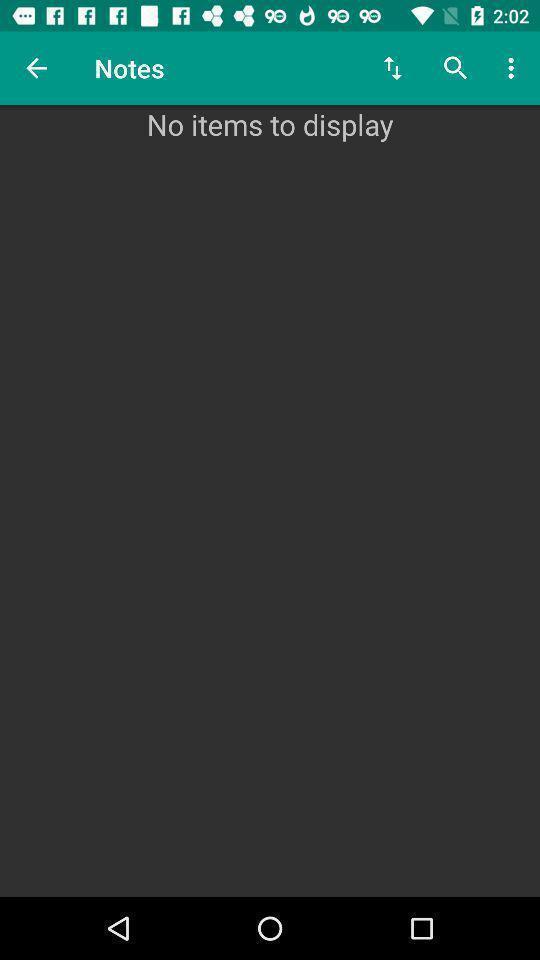Explain the elements present in this screenshot. Page with a search bar and no items. 